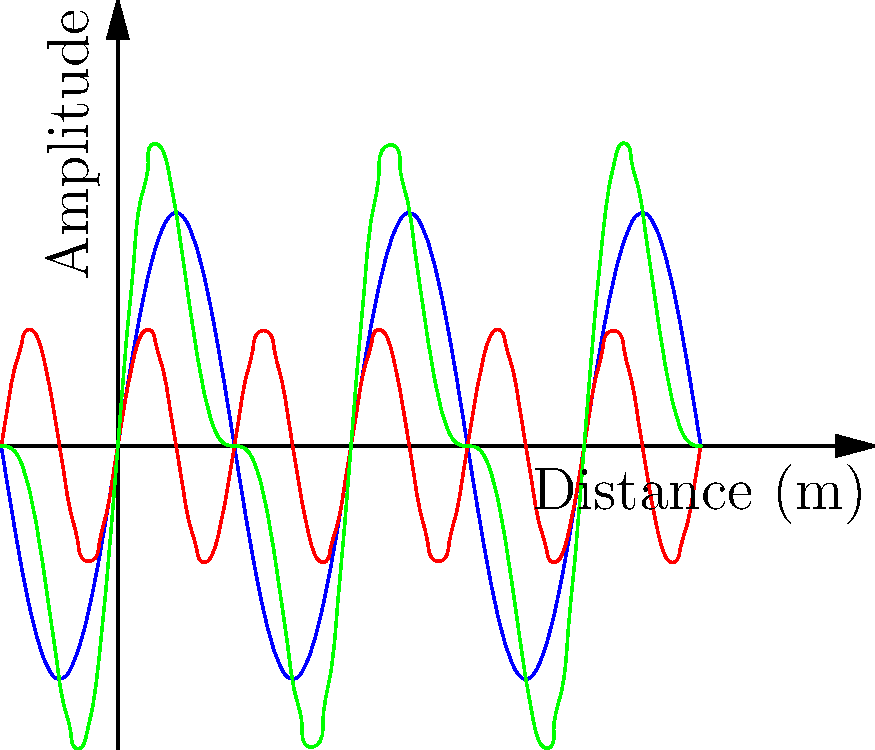In the context of electromagnetic wave propagation, analyze the graph showing two signals and their combination. If Signal 1 represents a primary communication channel and Signal 2 is an interfering signal, what phenomenon is illustrated by the green curve, and how might this impact secure communications between law enforcement and cybersecurity agencies? 1. Signal analysis:
   - Blue curve (Signal 1): Primary communication channel
   - Red curve (Signal 2): Interfering signal
   - Green curve: Combination of Signals 1 and 2

2. Phenomenon illustrated:
   The green curve represents the superposition of the two signals, demonstrating constructive and destructive interference.

3. Mathematical representation:
   Combined signal = Signal 1 + Signal 2
   $$h(x) = f(x) + g(x) = \sin(2\pi x) + 0.5\sin(4\pi x)$$

4. Impact on secure communications:
   a) Signal distortion: The original message (Signal 1) is altered by the interference.
   b) Reduced signal-to-noise ratio (SNR): The presence of interference decreases the quality of the received signal.
   c) Potential information leakage: Interfering signals may contain sensitive information or be used for eavesdropping.
   d) Increased vulnerability to interception: Weakened signals may be more susceptible to unauthorized access.

5. Implications for law enforcement and cybersecurity agencies:
   a) Need for robust encryption methods to protect against signal interception.
   b) Implementation of frequency hopping or spread spectrum techniques to mitigate interference.
   c) Regular monitoring of communication channels for potential interference or jamming attempts.
   d) Development of advanced signal processing algorithms to filter out interference and recover original signals.
Answer: Superposition and interference, potentially compromising secure communications through signal distortion, reduced SNR, and increased vulnerability to interception. 